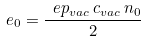Convert formula to latex. <formula><loc_0><loc_0><loc_500><loc_500>e _ { 0 } = \frac { \ e p _ { v a c } \, c _ { v a c } \, n _ { 0 } } { 2 }</formula> 